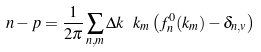<formula> <loc_0><loc_0><loc_500><loc_500>n - p = \frac { 1 } { 2 \pi } \sum _ { n , m } \Delta k \ k _ { m } \left ( f _ { n } ^ { 0 } ( k _ { m } ) - \delta _ { n , v } \right )</formula> 